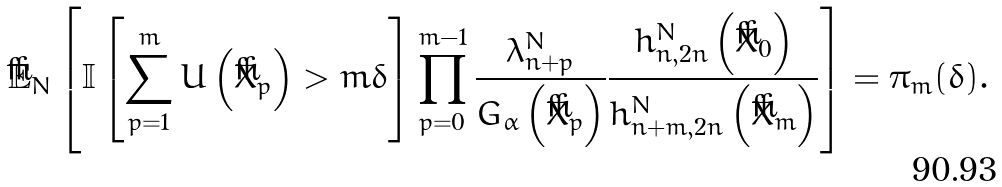<formula> <loc_0><loc_0><loc_500><loc_500>\check { \mathbb { E } } _ { N } \left [ \mathbb { I } \left [ \sum _ { p = 1 } ^ { m } U \left ( \check { X } _ { p } \right ) > m \delta \right ] \prod _ { p = 0 } ^ { m - 1 } \frac { \lambda _ { n + p } ^ { N } } { G _ { \alpha } \left ( \check { X } _ { p } \right ) } \frac { h _ { n , 2 n } ^ { N } \left ( \check { X } _ { 0 } \right ) } { h _ { n + m , 2 n } ^ { N } \left ( \check { X } _ { m } \right ) } \right ] = \pi _ { m } ( \delta ) .</formula> 